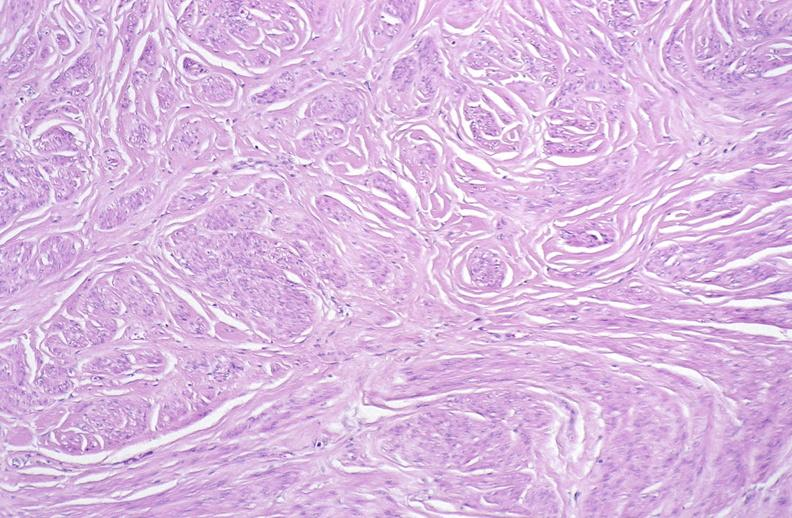where is this from?
Answer the question using a single word or phrase. Female reproductive system 